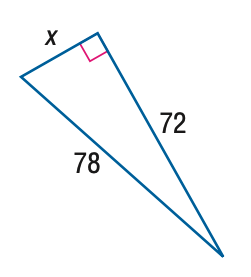Question: Use a Pythagorean Triple to find x.
Choices:
A. 26
B. 28
C. 30
D. 32
Answer with the letter. Answer: C 